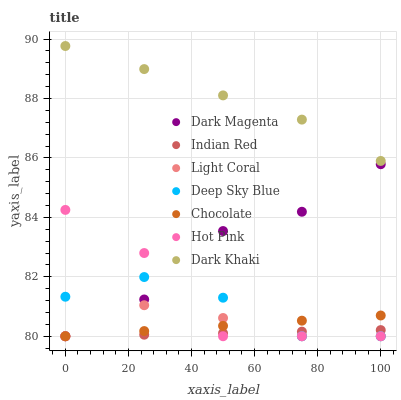Does Indian Red have the minimum area under the curve?
Answer yes or no. Yes. Does Dark Khaki have the maximum area under the curve?
Answer yes or no. Yes. Does Dark Magenta have the minimum area under the curve?
Answer yes or no. No. Does Dark Magenta have the maximum area under the curve?
Answer yes or no. No. Is Chocolate the smoothest?
Answer yes or no. Yes. Is Hot Pink the roughest?
Answer yes or no. Yes. Is Dark Magenta the smoothest?
Answer yes or no. No. Is Dark Magenta the roughest?
Answer yes or no. No. Does Dark Magenta have the lowest value?
Answer yes or no. Yes. Does Dark Khaki have the highest value?
Answer yes or no. Yes. Does Dark Magenta have the highest value?
Answer yes or no. No. Is Deep Sky Blue less than Dark Khaki?
Answer yes or no. Yes. Is Dark Khaki greater than Indian Red?
Answer yes or no. Yes. Does Light Coral intersect Deep Sky Blue?
Answer yes or no. Yes. Is Light Coral less than Deep Sky Blue?
Answer yes or no. No. Is Light Coral greater than Deep Sky Blue?
Answer yes or no. No. Does Deep Sky Blue intersect Dark Khaki?
Answer yes or no. No. 